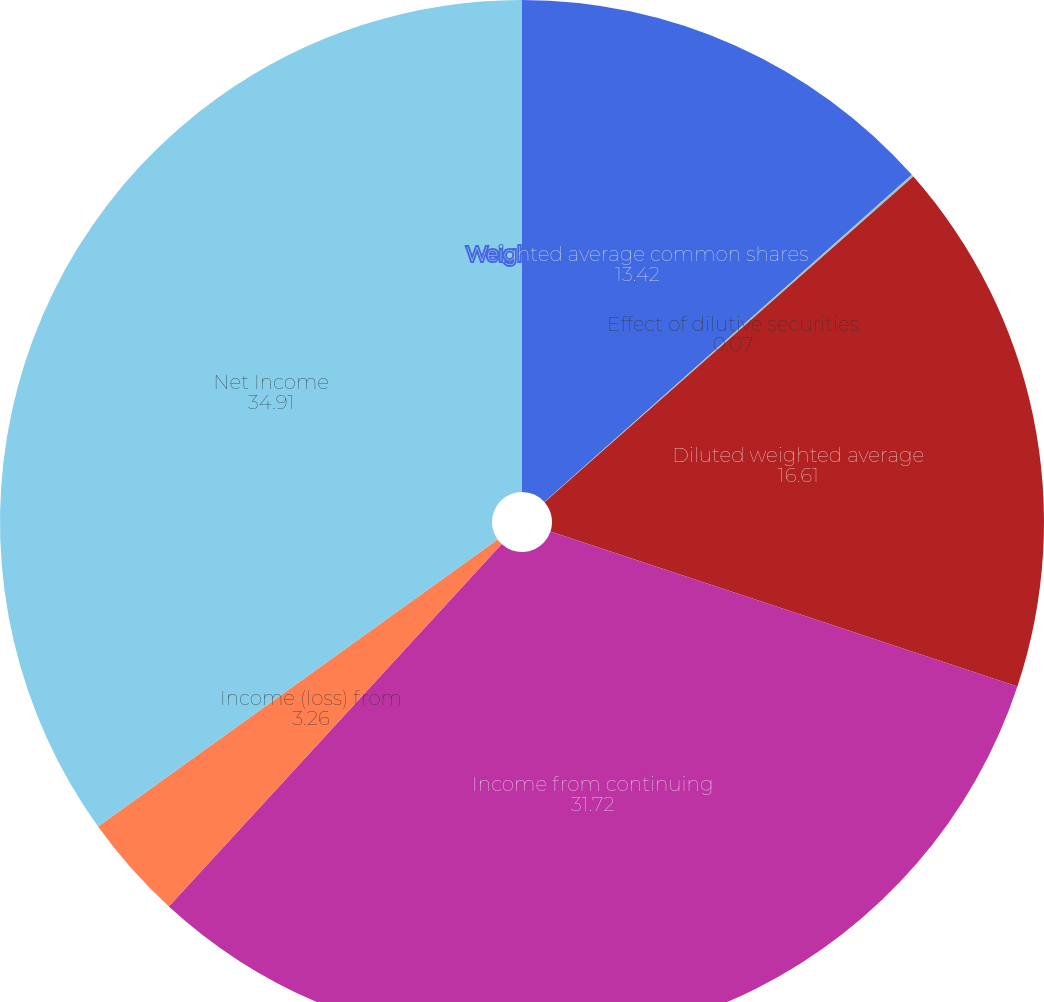Convert chart to OTSL. <chart><loc_0><loc_0><loc_500><loc_500><pie_chart><fcel>Weighted average common shares<fcel>Effect of dilutive securities<fcel>Diluted weighted average<fcel>Income from continuing<fcel>Income (loss) from<fcel>Net Income<nl><fcel>13.42%<fcel>0.07%<fcel>16.61%<fcel>31.72%<fcel>3.26%<fcel>34.91%<nl></chart> 